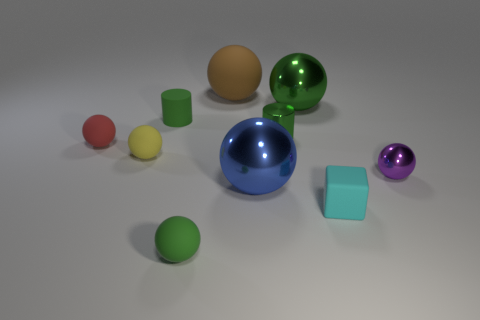Subtract 3 balls. How many balls are left? 4 Subtract all purple spheres. How many spheres are left? 6 Subtract all yellow rubber spheres. How many spheres are left? 6 Subtract all red spheres. Subtract all blue cylinders. How many spheres are left? 6 Subtract all cylinders. How many objects are left? 8 Add 4 blue spheres. How many blue spheres are left? 5 Add 8 blue balls. How many blue balls exist? 9 Subtract 0 brown blocks. How many objects are left? 10 Subtract all tiny metallic things. Subtract all spheres. How many objects are left? 1 